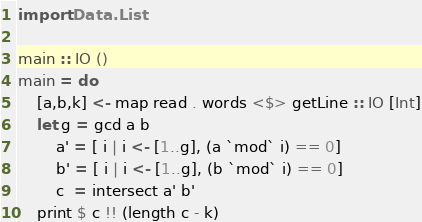Convert code to text. <code><loc_0><loc_0><loc_500><loc_500><_Haskell_>import Data.List

main :: IO ()
main = do
    [a,b,k] <- map read . words <$> getLine :: IO [Int]
    let g = gcd a b
        a' = [ i | i <- [1..g], (a `mod` i) == 0]
        b' = [ i | i <- [1..g], (b `mod` i) == 0]
        c  = intersect a' b'
    print $ c !! (length c - k)
</code> 